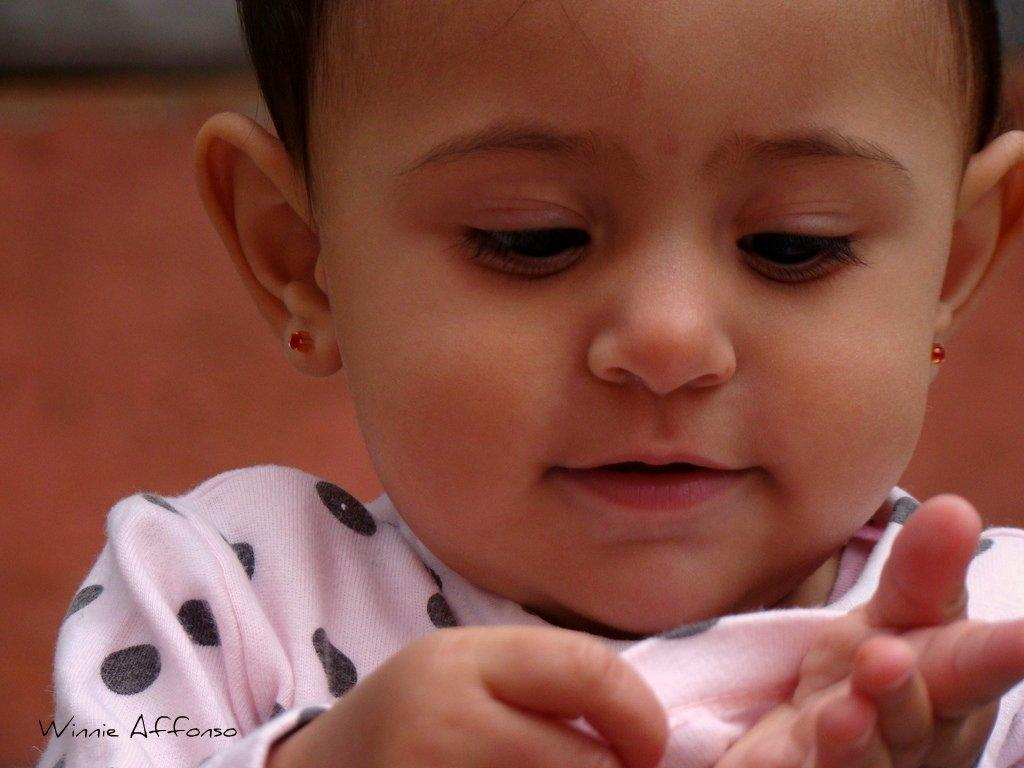What is the main subject of the image? There is a kid in the image. Can you describe the background of the image? The background of the image is blurred. How many cars are visible in the image? There are no cars present in the image; it features a kid with a blurred background. What type of locket is the kid wearing in the image? There is no locket visible in the image; the kid is the main subject, and no accessories are mentioned in the provided facts. 